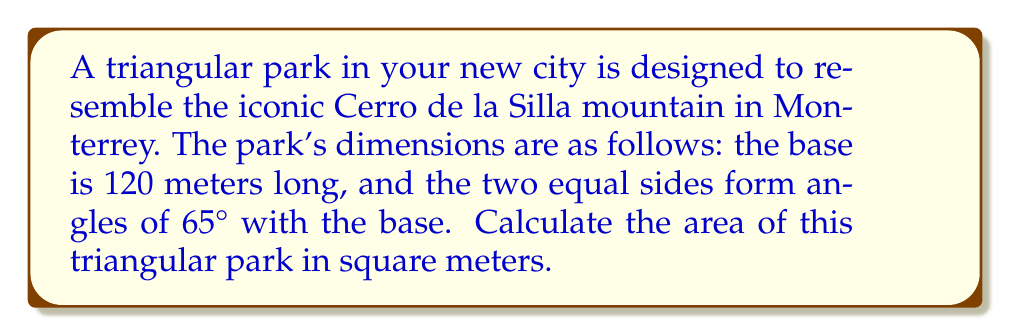Teach me how to tackle this problem. Let's approach this step-by-step:

1) First, we need to identify the type of triangle. Since two angles are equal (both 65°), this is an isosceles triangle.

2) We know that the sum of angles in a triangle is 180°. So we can find the third angle:
   $180° - (65° + 65°) = 50°$

3) Now we have a triangle with angles 65°, 65°, and 50°, and a base of 120 meters.

4) To find the area, we need the height of the triangle. We can split the isosceles triangle into two right triangles and use trigonometry.

5) In one of these right triangles, we know:
   - The angle adjacent to the base is 25° (half of 50°)
   - The hypotenuse is one of the equal sides, let's call it $s$
   - Half of the base is 60 meters (120/2)

6) Using the cosine function:
   $\cos(25°) = \frac{60}{s}$

7) Solving for $s$:
   $s = \frac{60}{\cos(25°)} \approx 66.15$ meters

8) Now we can find the height $h$ using the Pythagorean theorem:
   $h^2 = s^2 - 60^2$
   $h = \sqrt{66.15^2 - 60^2} \approx 28.28$ meters

9) The area of a triangle is given by the formula: $A = \frac{1}{2} \times base \times height$

10) Substituting our values:
    $A = \frac{1}{2} \times 120 \times 28.28 \approx 1696.8$ square meters

[asy]
import geometry;

size(200);
pair A = (0,0), B = (120,0), C = (60,28.28);
draw(A--B--C--cycle);
draw(C--(60,0),dashed);
label("120 m", (60,-5), S);
label("28.28 m", (65,14), E);
label("65°", (5,5), NW);
label("65°", (115,5), NE);
label("50°", (60,30), N);
[/asy]
Answer: $$1696.8 \text{ m}^2$$ 